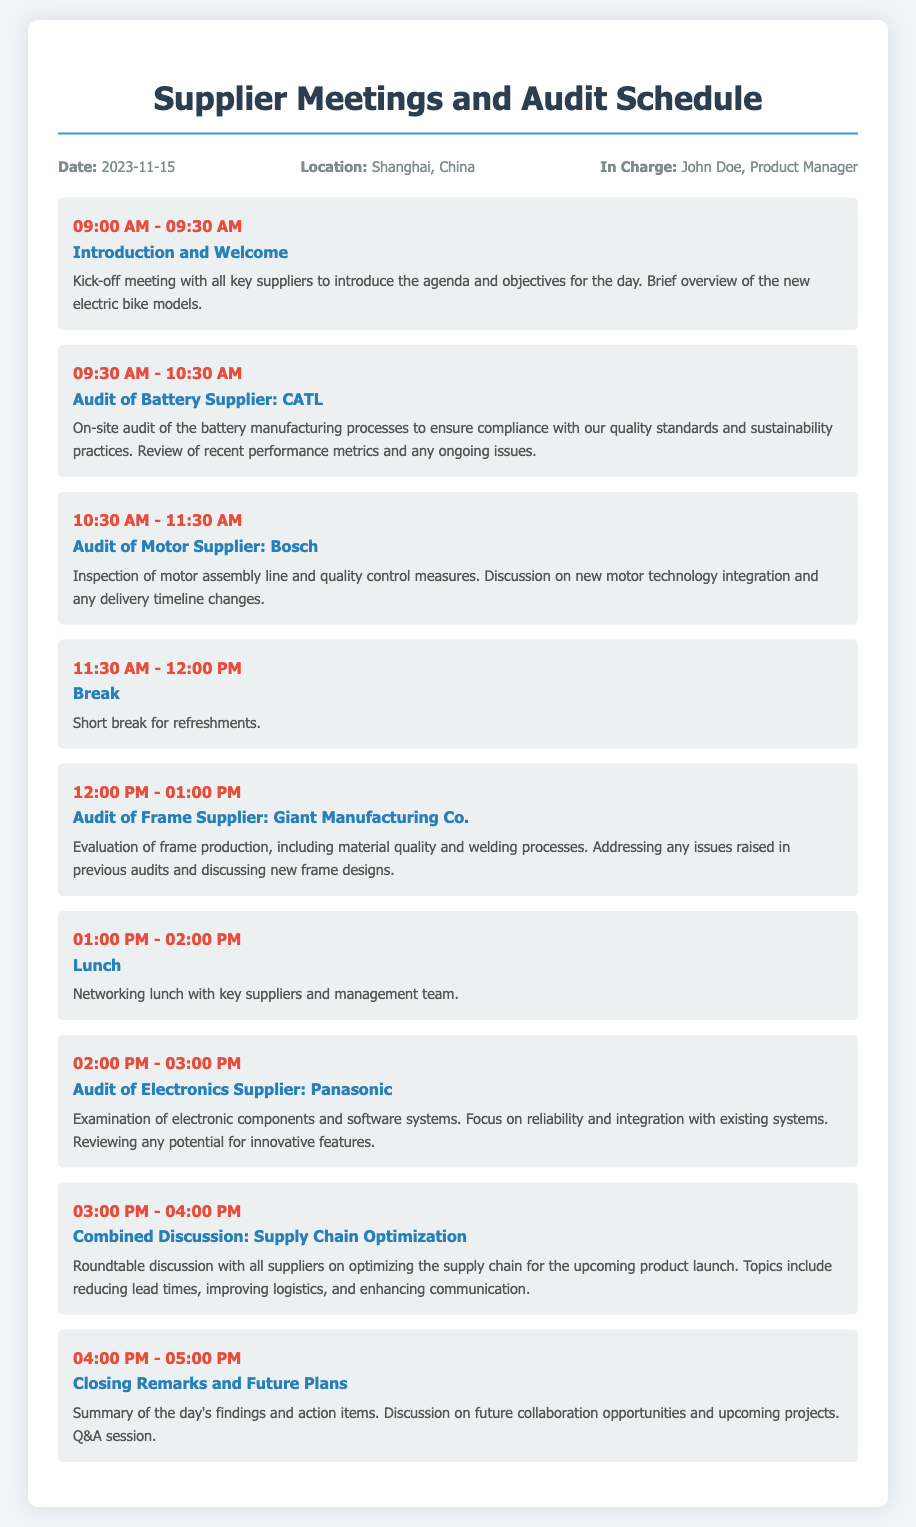What is the date of the meetings? The date of the meetings is explicitly stated in the header information of the document.
Answer: 2023-11-15 Who is in charge of the meetings? The document specifies the person responsible for overseeing the meetings in the header info.
Answer: John Doe What time does the lunch break start? The lunch break is listed with specific timing in the agenda section of the document.
Answer: 01:00 PM What supplier is being audited for motors? The agenda specifies which supplier is involved in the audit for motors.
Answer: Bosch What is the purpose of the closing remarks session? The details of the closing remarks session outline its primary focus in the agenda.
Answer: Summary of the day's findings How long is the welcome meeting? The duration of the introductory session is specified in the agenda.
Answer: 30 minutes What is discussed during the combined discussion? The document states the topics covered during the roundtable discussion in the agenda section.
Answer: Supply Chain Optimization What is the location of the meetings? The location is mentioned in the header information of the document.
Answer: Shanghai, China 